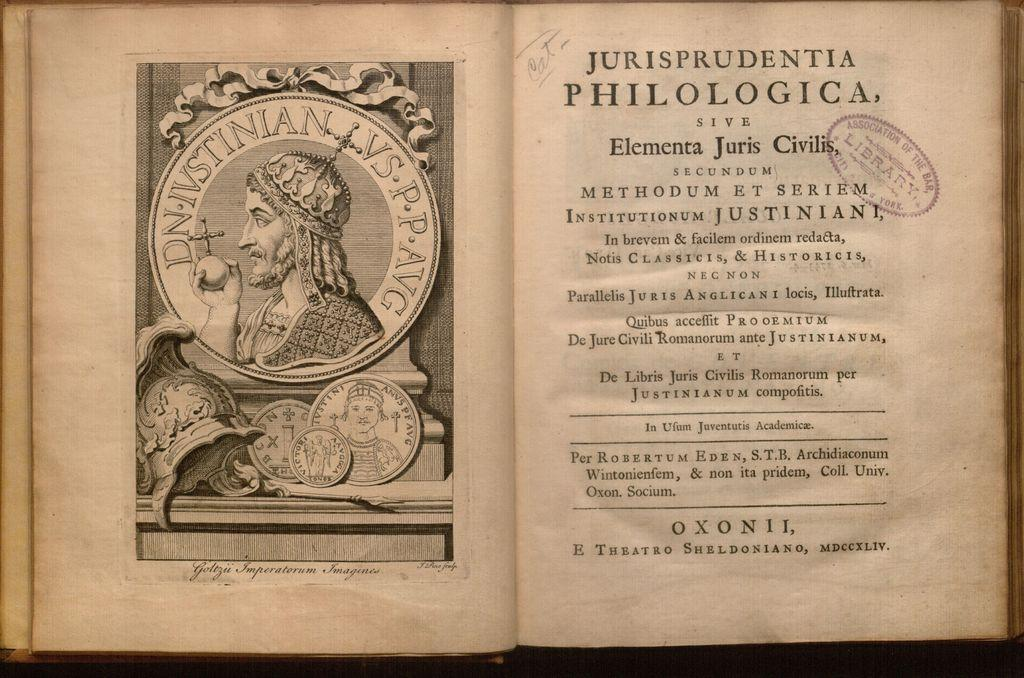<image>
Give a short and clear explanation of the subsequent image. The book Jurisprudentia Philologica is open to a page. 